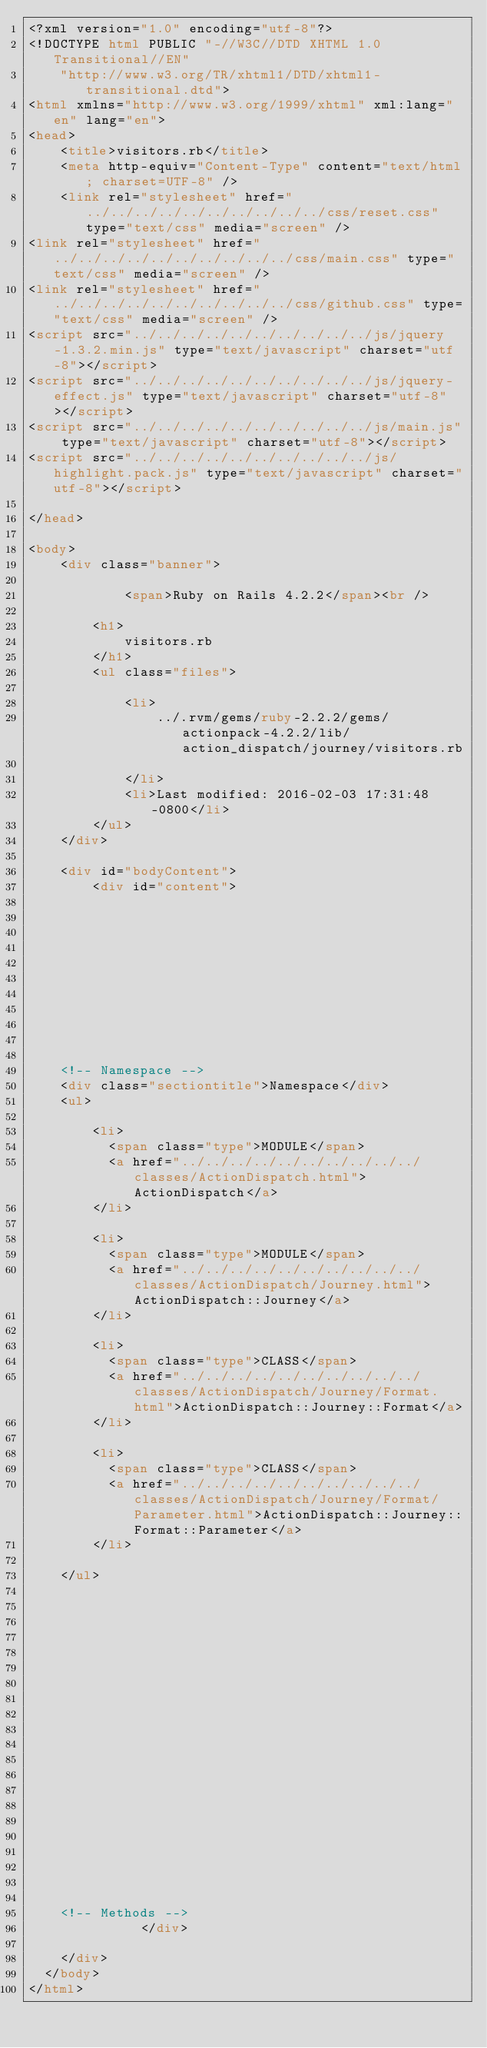Convert code to text. <code><loc_0><loc_0><loc_500><loc_500><_HTML_><?xml version="1.0" encoding="utf-8"?>
<!DOCTYPE html PUBLIC "-//W3C//DTD XHTML 1.0 Transitional//EN"
    "http://www.w3.org/TR/xhtml1/DTD/xhtml1-transitional.dtd">
<html xmlns="http://www.w3.org/1999/xhtml" xml:lang="en" lang="en">
<head>
    <title>visitors.rb</title>
    <meta http-equiv="Content-Type" content="text/html; charset=UTF-8" />
    <link rel="stylesheet" href="../../../../../../../../../../css/reset.css" type="text/css" media="screen" />
<link rel="stylesheet" href="../../../../../../../../../../css/main.css" type="text/css" media="screen" />
<link rel="stylesheet" href="../../../../../../../../../../css/github.css" type="text/css" media="screen" />
<script src="../../../../../../../../../../js/jquery-1.3.2.min.js" type="text/javascript" charset="utf-8"></script>
<script src="../../../../../../../../../../js/jquery-effect.js" type="text/javascript" charset="utf-8"></script>
<script src="../../../../../../../../../../js/main.js" type="text/javascript" charset="utf-8"></script>
<script src="../../../../../../../../../../js/highlight.pack.js" type="text/javascript" charset="utf-8"></script>

</head>

<body>     
    <div class="banner">
        
            <span>Ruby on Rails 4.2.2</span><br />
        
        <h1>
            visitors.rb
        </h1>
        <ul class="files">
            
            <li>
                ../.rvm/gems/ruby-2.2.2/gems/actionpack-4.2.2/lib/action_dispatch/journey/visitors.rb
                
            </li>
            <li>Last modified: 2016-02-03 17:31:48 -0800</li>
        </ul>
    </div>

    <div id="bodyContent">
        <div id="content">
  


  


  
  


  
    <!-- Namespace -->
    <div class="sectiontitle">Namespace</div>
    <ul>
      
        <li>
          <span class="type">MODULE</span>
          <a href="../../../../../../../../../../classes/ActionDispatch.html">ActionDispatch</a>
        </li>
      
        <li>
          <span class="type">MODULE</span>
          <a href="../../../../../../../../../../classes/ActionDispatch/Journey.html">ActionDispatch::Journey</a>
        </li>
      
        <li>
          <span class="type">CLASS</span>
          <a href="../../../../../../../../../../classes/ActionDispatch/Journey/Format.html">ActionDispatch::Journey::Format</a>
        </li>
      
        <li>
          <span class="type">CLASS</span>
          <a href="../../../../../../../../../../classes/ActionDispatch/Journey/Format/Parameter.html">ActionDispatch::Journey::Format::Parameter</a>
        </li>
      
    </ul>
  


  

  



  

    

    

    


    


    <!-- Methods -->
              </div>

    </div>
  </body>
</html></code> 